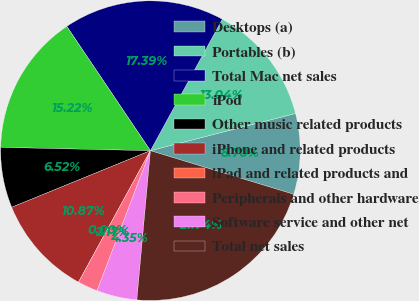Convert chart to OTSL. <chart><loc_0><loc_0><loc_500><loc_500><pie_chart><fcel>Desktops (a)<fcel>Portables (b)<fcel>Total Mac net sales<fcel>iPod<fcel>Other music related products<fcel>iPhone and related products<fcel>iPad and related products and<fcel>Peripherals and other hardware<fcel>Software service and other net<fcel>Total net sales<nl><fcel>8.7%<fcel>13.04%<fcel>17.39%<fcel>15.22%<fcel>6.52%<fcel>10.87%<fcel>0.0%<fcel>2.17%<fcel>4.35%<fcel>21.74%<nl></chart> 